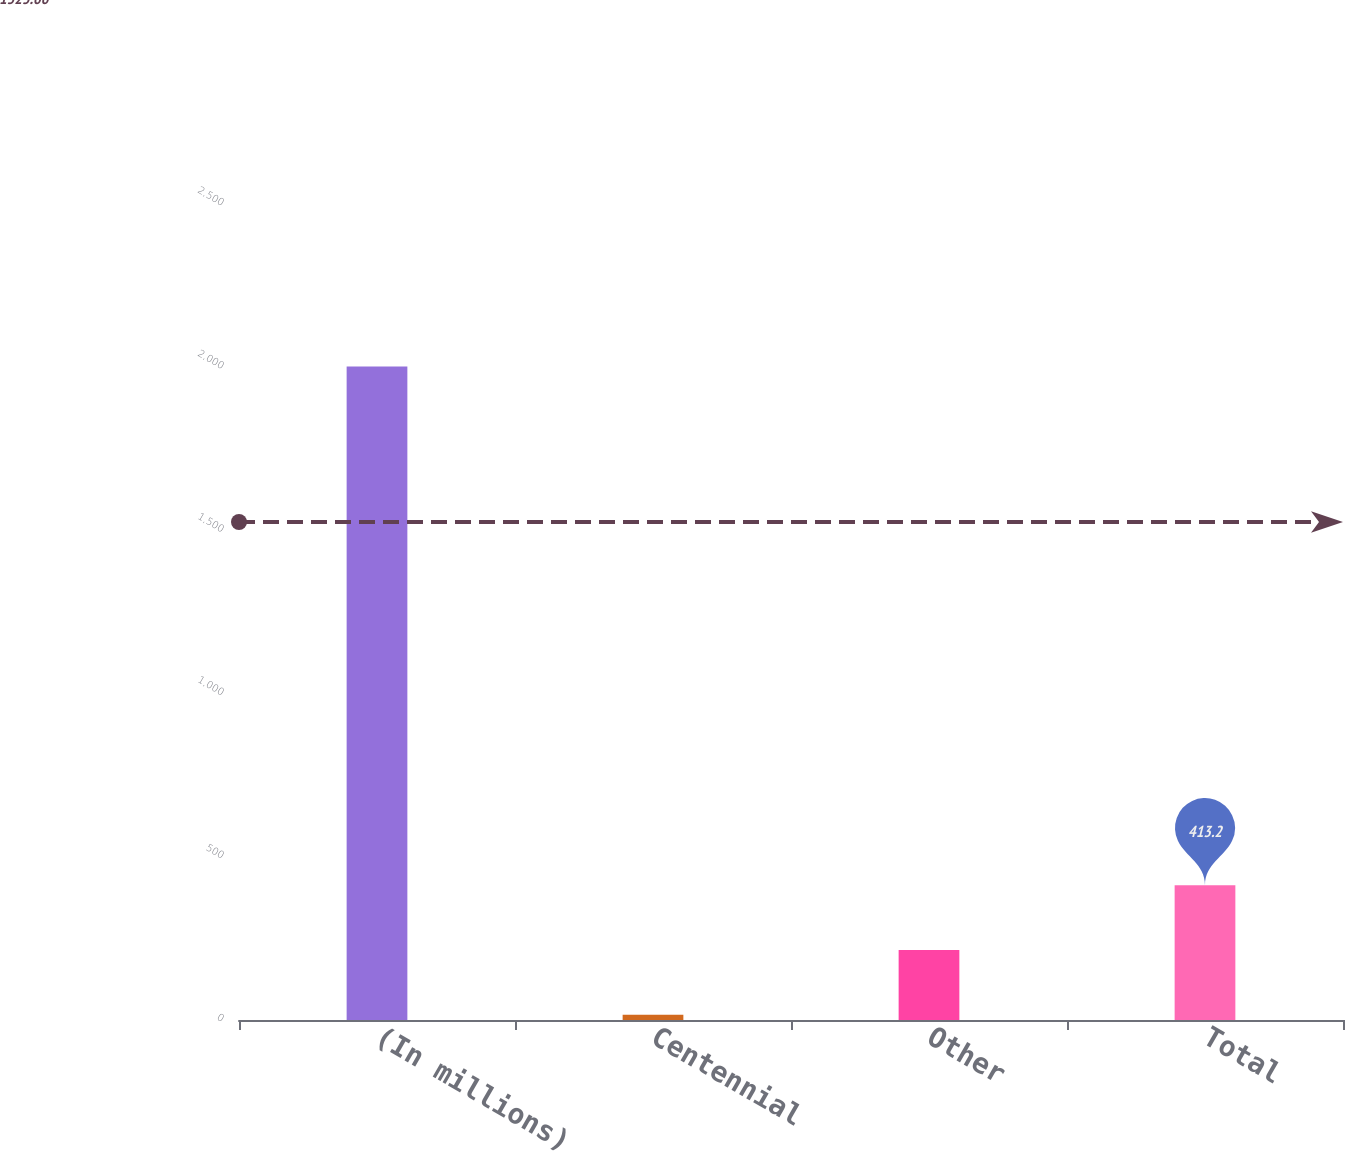<chart> <loc_0><loc_0><loc_500><loc_500><bar_chart><fcel>(In millions)<fcel>Centennial<fcel>Other<fcel>Total<nl><fcel>2002<fcel>16<fcel>214.6<fcel>413.2<nl></chart> 